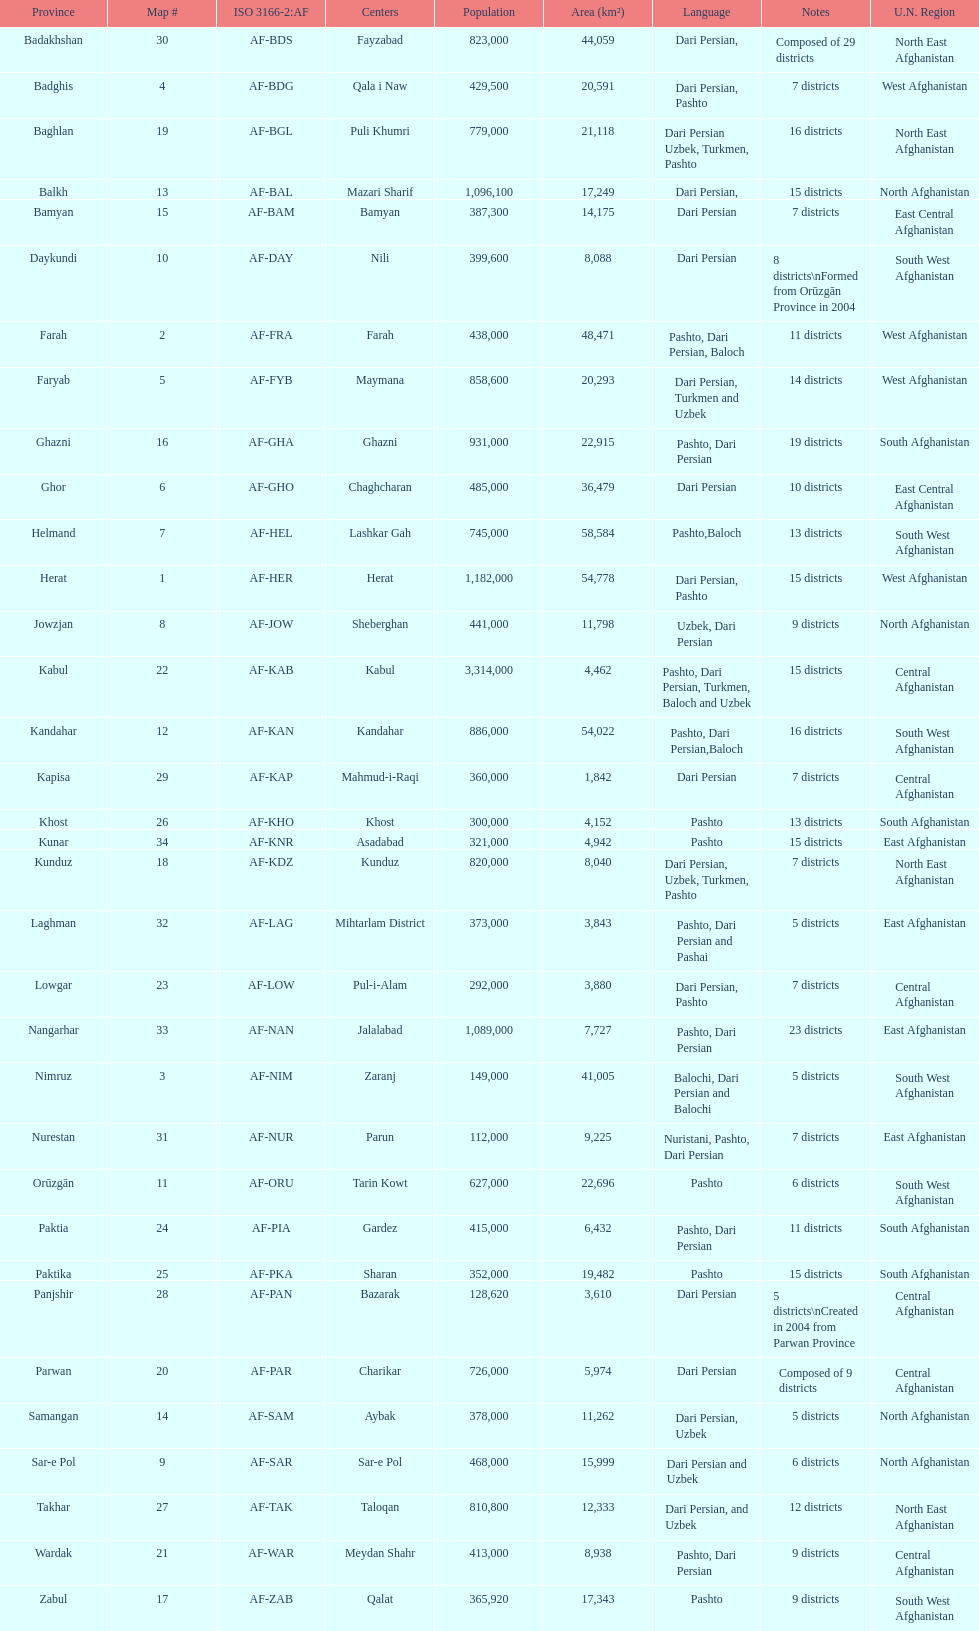Between ghor and farah, which one has more districts? Farah. 